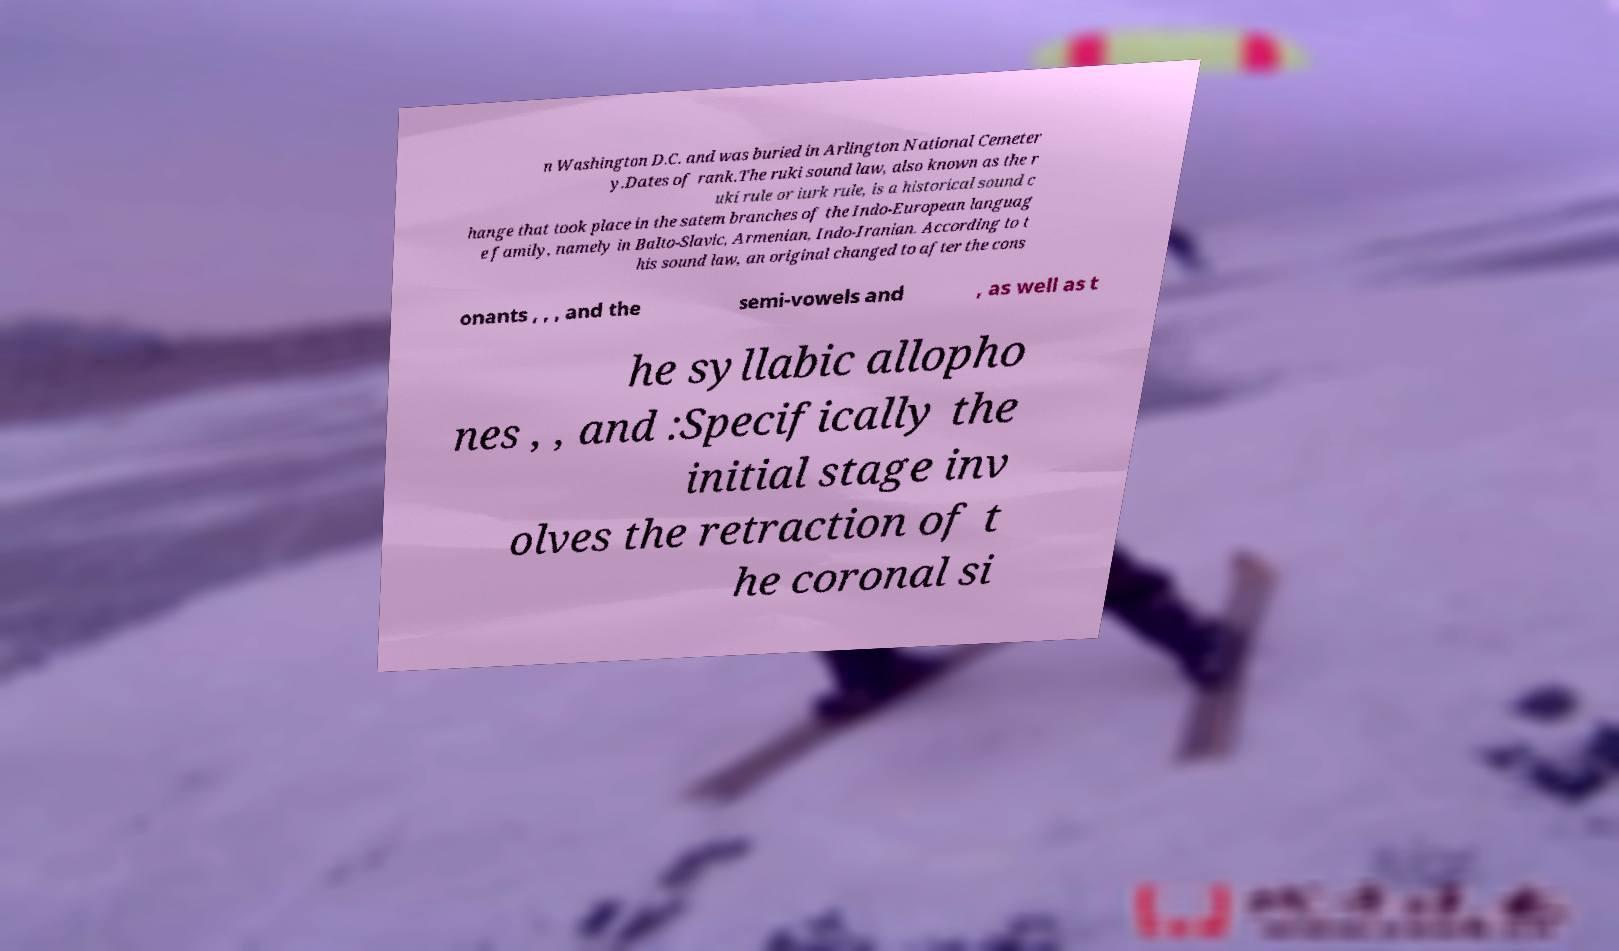Could you assist in decoding the text presented in this image and type it out clearly? n Washington D.C. and was buried in Arlington National Cemeter y.Dates of rank.The ruki sound law, also known as the r uki rule or iurk rule, is a historical sound c hange that took place in the satem branches of the Indo-European languag e family, namely in Balto-Slavic, Armenian, Indo-Iranian. According to t his sound law, an original changed to after the cons onants , , , and the semi-vowels and , as well as t he syllabic allopho nes , , and :Specifically the initial stage inv olves the retraction of t he coronal si 